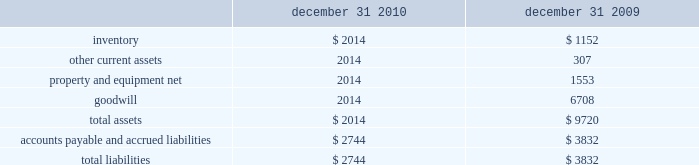Revenue from other sources includes scrap sales , bulk sales to mechanical remanufacturers , and sales of aluminum ingots and sows .
Foreign currency translation for our foreign operations , the local currency is the functional currency .
Assets and liabilities are translated into u.s .
Dollars at the period-ending exchange rate .
Statements of income amounts are translated to u.s .
Dollars using average exchange rates during the period .
Translation gains and losses are reported as a component of accumulated other comprehensive income ( loss ) in stockholders 2019 equity .
Gains and losses from foreign currency transactions are included in current earnings .
Recent accounting pronouncements on january 1 , 2011 , we will adopt financial accounting standards board accounting standards update 2010-29 , 201cdisclosure of supplementary pro forma information for business combinations , 201d which clarifies the disclosure requirements for pro forma financial information related to a material business combination or a series of immaterial business combinations that are material in the aggregate .
The guidance clarified that the pro forma disclosures are prepared assuming the business combination occurred at the start of the prior annual reporting period .
Additionally , a narrative description of the nature and amount of material , non-recurring pro forma adjustments would be required .
As this newly issued accounting standard only requires enhanced disclosure , the adoption of this standard will not impact our financial position or results of operations .
Note 3 .
Discontinued operations on october 1 , 2009 , we sold to schnitzer steel industries , inc .
( 201cssi 201d ) four self service retail facilities in oregon and washington and certain business assets related to two self service facilities in northern california and a self service facility in portland , oregon for $ 17.5 million , net of cash sold .
We recognized a gain on the sale of approximately $ 2.5 million , net of tax , in our fourth quarter 2009 results .
Goodwill totaling $ 9.9 million was included in the cost basis of net assets disposed when determining the gain on sale .
In the fourth quarter of 2009 , we closed the two self service facilities in northern california and converted the self service operation in portland to a wholesale recycling business .
On january 15 , 2010 , we also sold to ssi two self service retail facilities in dallas , texas for $ 12.0 million .
We recognized a gain on the sale of approximately $ 1.7 million , net of tax , in our first quarter 2010 results .
Goodwill totaling $ 6.7 million was included in the cost basis of net assets disposed when determining the gain on the self service facilities that we sold or closed are reported as discontinued operations for all periods presented .
We reported these facilities in discontinued operations because the cash flows derived from the facilities were eliminated as a result of the sales or closures , and we will not have continuing involvement in these facilities .
A summary of the assets and liabilities applicable to discontinued operations included in the consolidated balance sheets as of december 31 , 2010 and 2009 is as follows ( in thousands ) : december 31 , december 31 .

What was the ratio of the accounts payable and accrued liabilities in 2010 compared to 2009? 
Computations: (2744 / 3832)
Answer: 0.71608. 